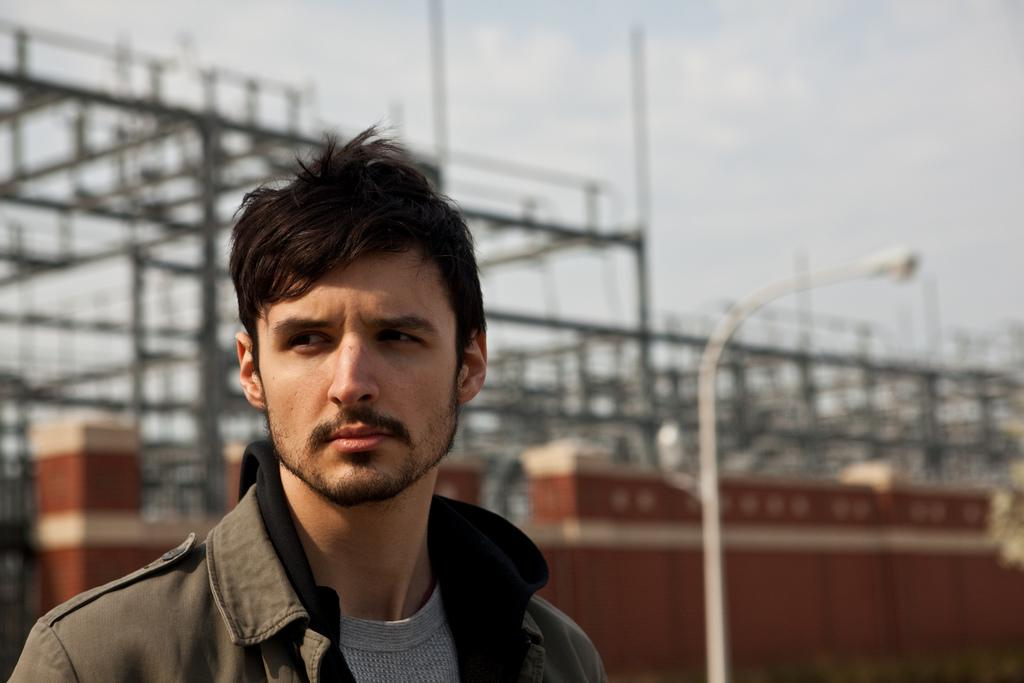Who or what is present in the image? There is a person in the image. What is located behind the person? There is a street light behind the person. What type of structure is visible in the image? There is a wall in the image. What objects are present in the image that resemble long, thin bars? There are rods in the image. What can be seen in the background of the image? The sky is visible in the background of the image. How does the person change the fuel in the image? There is no mention of fuel or any vehicle in the image, so it is not possible to answer this question. 